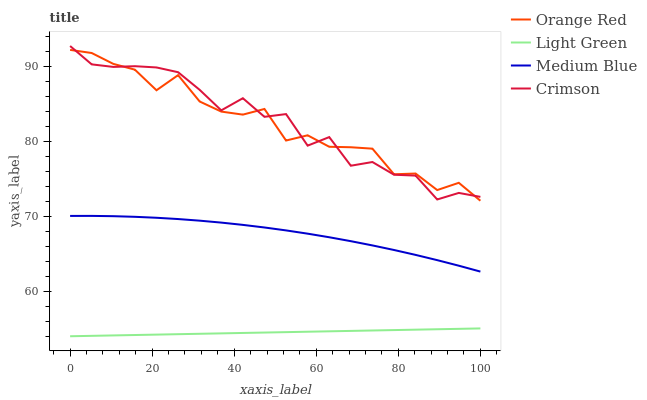Does Light Green have the minimum area under the curve?
Answer yes or no. Yes. Does Crimson have the maximum area under the curve?
Answer yes or no. Yes. Does Medium Blue have the minimum area under the curve?
Answer yes or no. No. Does Medium Blue have the maximum area under the curve?
Answer yes or no. No. Is Light Green the smoothest?
Answer yes or no. Yes. Is Crimson the roughest?
Answer yes or no. Yes. Is Medium Blue the smoothest?
Answer yes or no. No. Is Medium Blue the roughest?
Answer yes or no. No. Does Medium Blue have the lowest value?
Answer yes or no. No. Does Medium Blue have the highest value?
Answer yes or no. No. Is Light Green less than Medium Blue?
Answer yes or no. Yes. Is Orange Red greater than Light Green?
Answer yes or no. Yes. Does Light Green intersect Medium Blue?
Answer yes or no. No. 